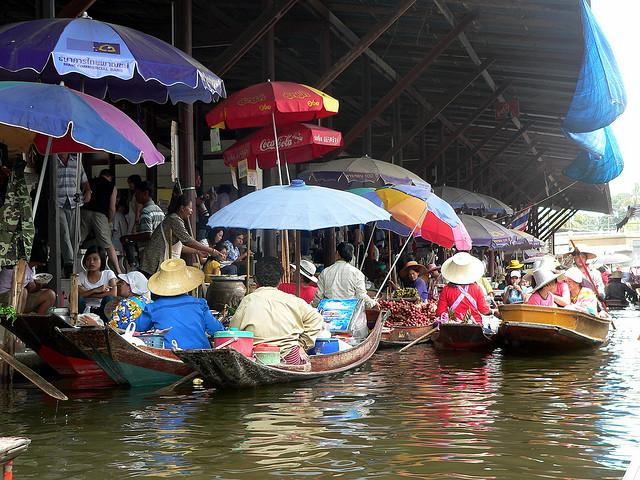What is the woman with a big blue umbrella doing?

Choices:
A) sightseeing
B) boat racing
C) commuting
D) selling stuff selling stuff 